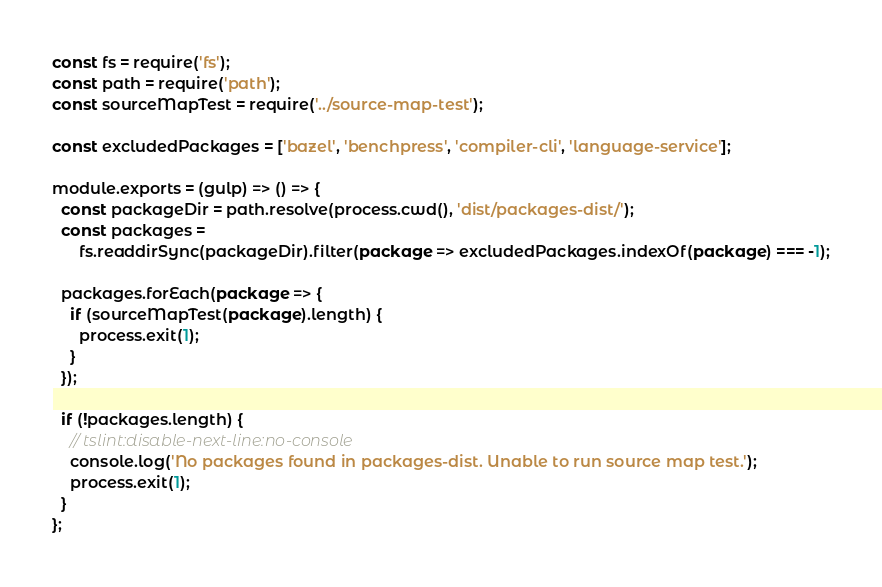<code> <loc_0><loc_0><loc_500><loc_500><_JavaScript_>const fs = require('fs');
const path = require('path');
const sourceMapTest = require('../source-map-test');

const excludedPackages = ['bazel', 'benchpress', 'compiler-cli', 'language-service'];

module.exports = (gulp) => () => {
  const packageDir = path.resolve(process.cwd(), 'dist/packages-dist/');
  const packages =
      fs.readdirSync(packageDir).filter(package => excludedPackages.indexOf(package) === -1);

  packages.forEach(package => {
    if (sourceMapTest(package).length) {
      process.exit(1);
    }
  });

  if (!packages.length) {
    // tslint:disable-next-line:no-console
    console.log('No packages found in packages-dist. Unable to run source map test.');
    process.exit(1);
  }
};
</code> 